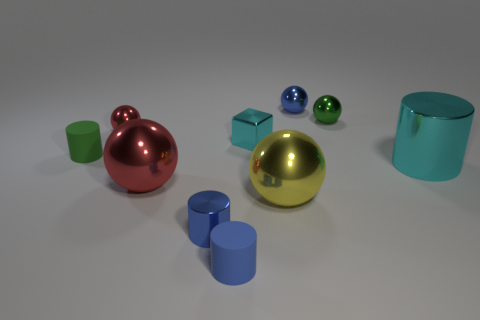Is the big cylinder the same color as the tiny metallic block?
Make the answer very short. Yes. How many yellow balls are there?
Your response must be concise. 1. What shape is the metal thing that is the same color as the large metal cylinder?
Give a very brief answer. Cube. What size is the blue metallic thing that is the same shape as the small green rubber thing?
Ensure brevity in your answer.  Small. There is a tiny rubber thing in front of the tiny green rubber cylinder; does it have the same shape as the large cyan metal thing?
Keep it short and to the point. Yes. The small cylinder that is behind the yellow thing is what color?
Provide a succinct answer. Green. What number of other things are there of the same size as the blue matte cylinder?
Provide a short and direct response. 6. Is there anything else that is the same shape as the big yellow object?
Make the answer very short. Yes. Are there the same number of tiny cyan things that are behind the tiny shiny block and tiny rubber things?
Your answer should be very brief. No. What number of big things are the same material as the cyan cube?
Offer a terse response. 3. 